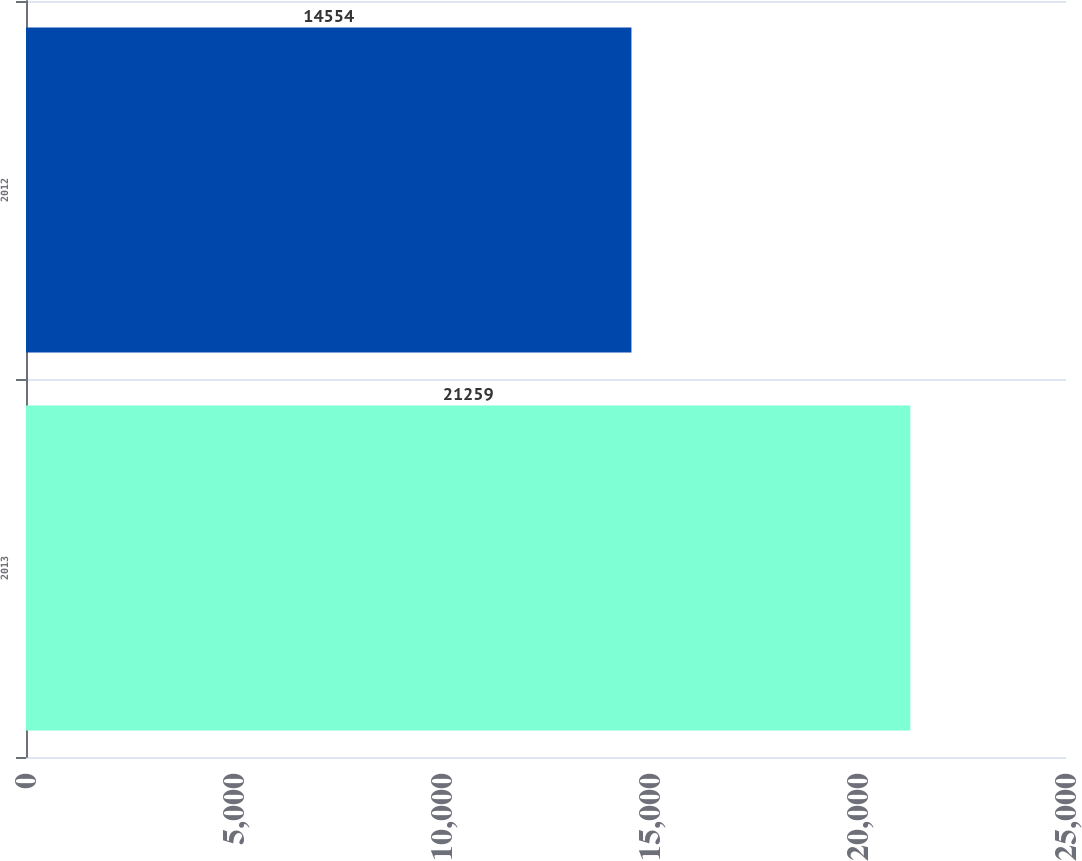Convert chart to OTSL. <chart><loc_0><loc_0><loc_500><loc_500><bar_chart><fcel>2013<fcel>2012<nl><fcel>21259<fcel>14554<nl></chart> 